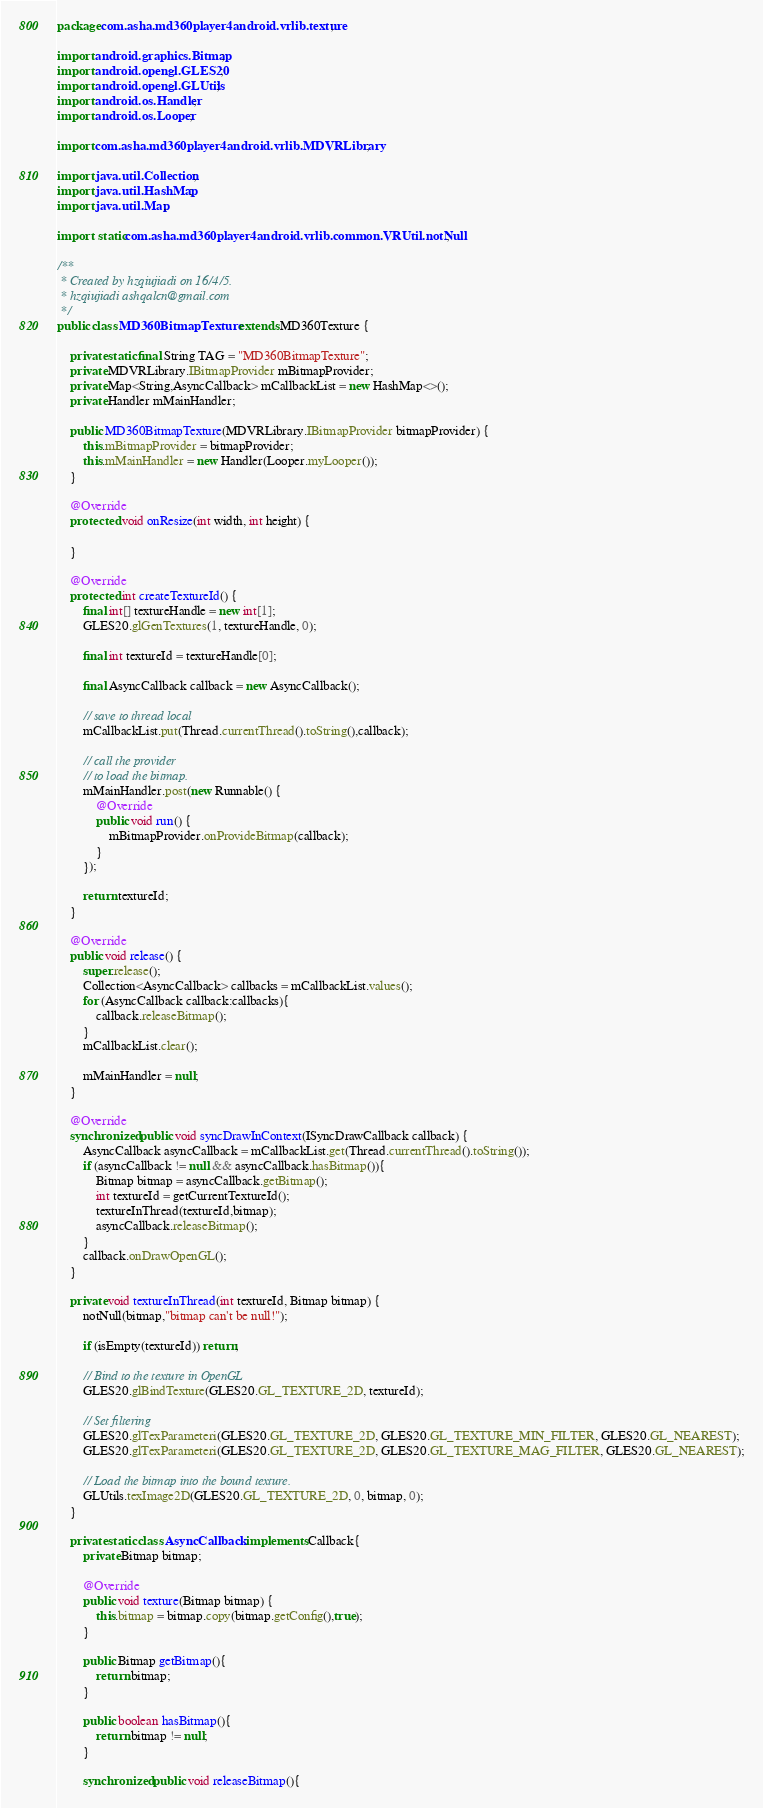Convert code to text. <code><loc_0><loc_0><loc_500><loc_500><_Java_>package com.asha.md360player4android.vrlib.texture;

import android.graphics.Bitmap;
import android.opengl.GLES20;
import android.opengl.GLUtils;
import android.os.Handler;
import android.os.Looper;

import com.asha.md360player4android.vrlib.MDVRLibrary;

import java.util.Collection;
import java.util.HashMap;
import java.util.Map;

import static com.asha.md360player4android.vrlib.common.VRUtil.notNull;

/**
 * Created by hzqiujiadi on 16/4/5.
 * hzqiujiadi ashqalcn@gmail.com
 */
public class MD360BitmapTexture extends MD360Texture {

    private static final String TAG = "MD360BitmapTexture";
    private MDVRLibrary.IBitmapProvider mBitmapProvider;
    private Map<String,AsyncCallback> mCallbackList = new HashMap<>();
    private Handler mMainHandler;

    public MD360BitmapTexture(MDVRLibrary.IBitmapProvider bitmapProvider) {
        this.mBitmapProvider = bitmapProvider;
        this.mMainHandler = new Handler(Looper.myLooper());
    }

    @Override
    protected void onResize(int width, int height) {

    }

    @Override
    protected int createTextureId() {
        final int[] textureHandle = new int[1];
        GLES20.glGenTextures(1, textureHandle, 0);

        final int textureId = textureHandle[0];

        final AsyncCallback callback = new AsyncCallback();

        // save to thread local
        mCallbackList.put(Thread.currentThread().toString(),callback);

        // call the provider
        // to load the bitmap.
        mMainHandler.post(new Runnable() {
            @Override
            public void run() {
                mBitmapProvider.onProvideBitmap(callback);
            }
        });

        return textureId;
    }

    @Override
    public void release() {
        super.release();
        Collection<AsyncCallback> callbacks = mCallbackList.values();
        for (AsyncCallback callback:callbacks){
            callback.releaseBitmap();
        }
        mCallbackList.clear();

        mMainHandler = null;
    }

    @Override
    synchronized public void syncDrawInContext(ISyncDrawCallback callback) {
        AsyncCallback asyncCallback = mCallbackList.get(Thread.currentThread().toString());
        if (asyncCallback != null && asyncCallback.hasBitmap()){
            Bitmap bitmap = asyncCallback.getBitmap();
            int textureId = getCurrentTextureId();
            textureInThread(textureId,bitmap);
            asyncCallback.releaseBitmap();
        }
        callback.onDrawOpenGL();
    }

    private void textureInThread(int textureId, Bitmap bitmap) {
        notNull(bitmap,"bitmap can't be null!");

        if (isEmpty(textureId)) return;

        // Bind to the texture in OpenGL
        GLES20.glBindTexture(GLES20.GL_TEXTURE_2D, textureId);

        // Set filtering
        GLES20.glTexParameteri(GLES20.GL_TEXTURE_2D, GLES20.GL_TEXTURE_MIN_FILTER, GLES20.GL_NEAREST);
        GLES20.glTexParameteri(GLES20.GL_TEXTURE_2D, GLES20.GL_TEXTURE_MAG_FILTER, GLES20.GL_NEAREST);

        // Load the bitmap into the bound texture.
        GLUtils.texImage2D(GLES20.GL_TEXTURE_2D, 0, bitmap, 0);
    }

    private static class AsyncCallback implements Callback{
        private Bitmap bitmap;

        @Override
        public void texture(Bitmap bitmap) {
            this.bitmap = bitmap.copy(bitmap.getConfig(),true);
        }

        public Bitmap getBitmap(){
            return bitmap;
        }

        public boolean hasBitmap(){
            return bitmap != null;
        }

        synchronized public void releaseBitmap(){</code> 